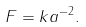Convert formula to latex. <formula><loc_0><loc_0><loc_500><loc_500>F = k a ^ { - 2 } .</formula> 